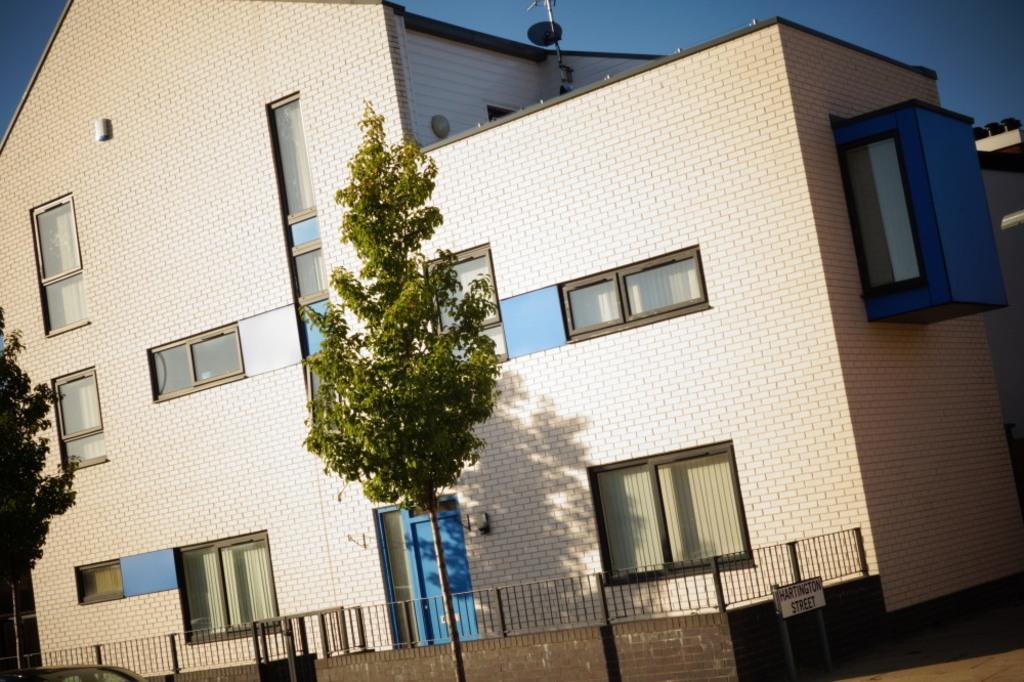Can you describe this image briefly? This picture consist of house, tree, wall, fence, sign board, windows, door, sky. 